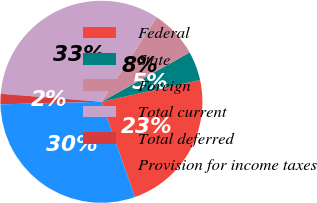Convert chart. <chart><loc_0><loc_0><loc_500><loc_500><pie_chart><fcel>Federal<fcel>State<fcel>Foreign<fcel>Total current<fcel>Total deferred<fcel>Provision for income taxes<nl><fcel>23.07%<fcel>4.66%<fcel>7.66%<fcel>32.97%<fcel>1.66%<fcel>29.98%<nl></chart> 